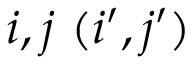Convert formula to latex. <formula><loc_0><loc_0><loc_500><loc_500>i , j ( i ^ { \prime } , j ^ { \prime } )</formula> 